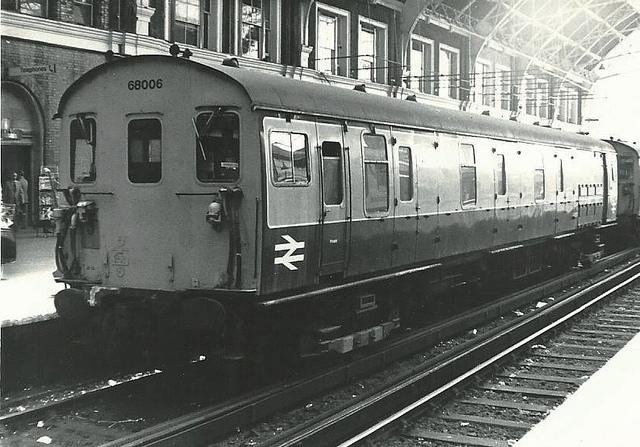Is this train in motion?
Quick response, please. No. What two numbers are repeated in the sequence on the back of the train?
Write a very short answer. 6 and 0. How many trains can be seen?
Answer briefly. 1. 